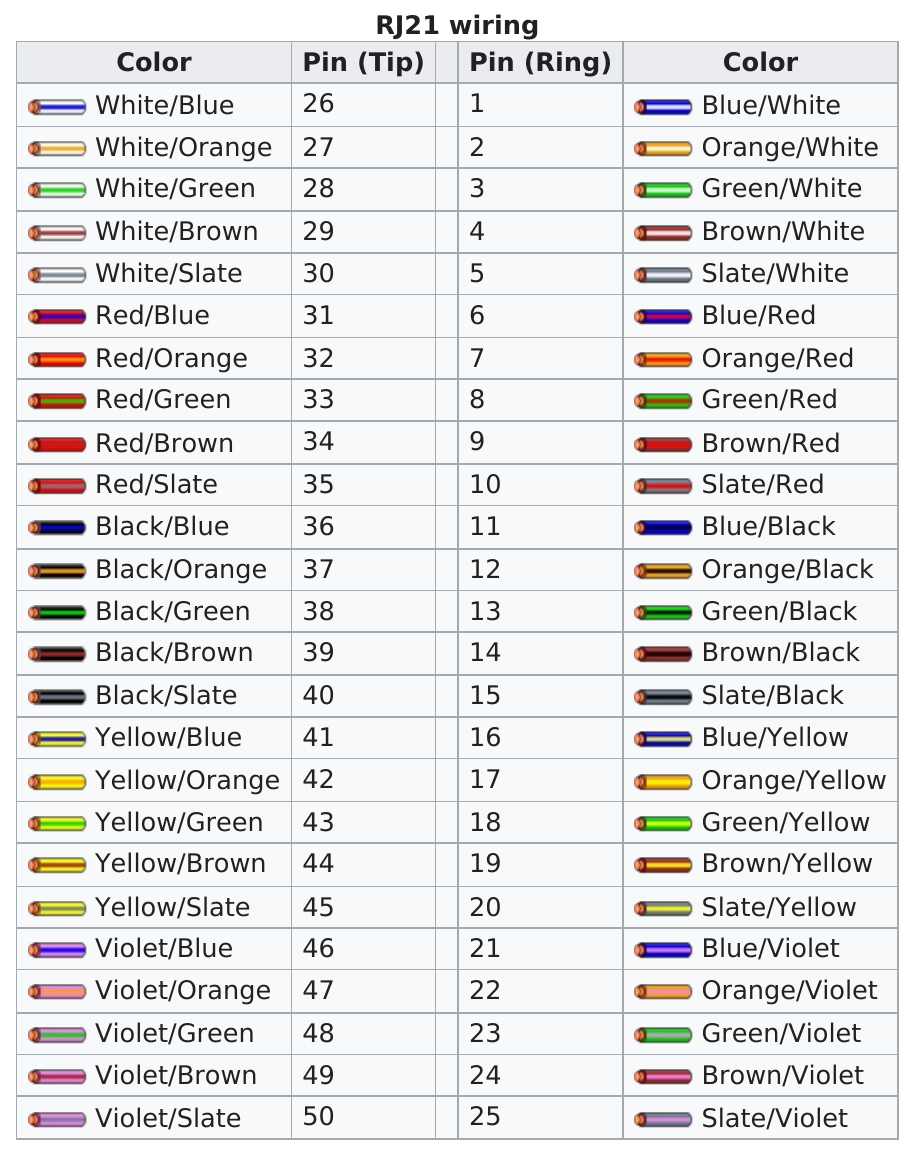Specify some key components in this picture. In the RJ21 wiring table, the color above black/slate is black/brown. There is one color named white in the RJ21 wiring table. The number of this color is 10. The RJ21 wiring table has a blue/white wire located in the top right corner. 